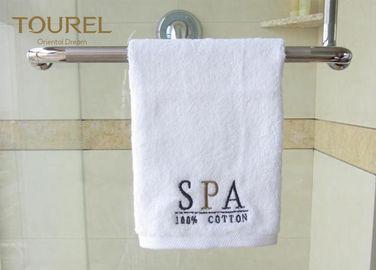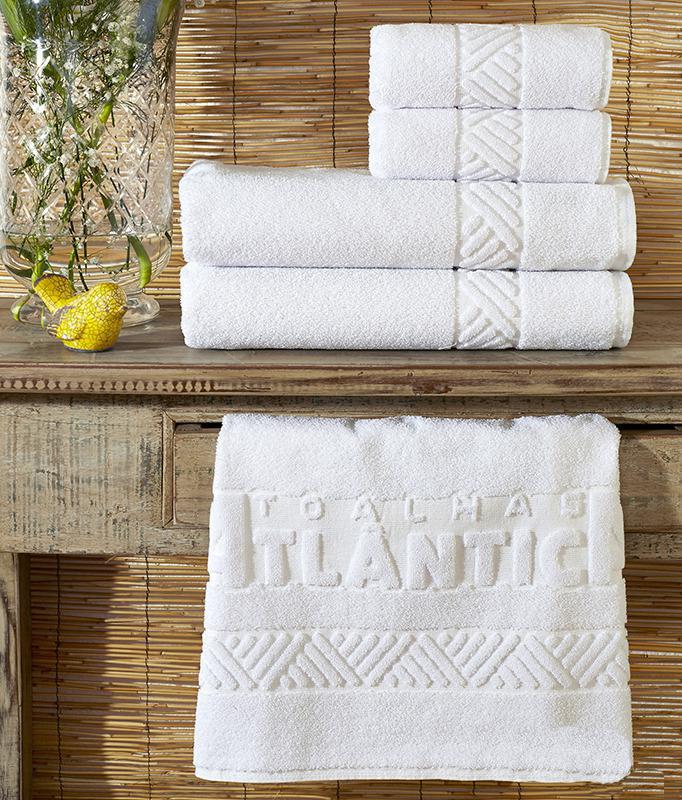The first image is the image on the left, the second image is the image on the right. Considering the images on both sides, is "The left image shows three white towels with the Sheraton logo stacked on top of each other." valid? Answer yes or no. No. The first image is the image on the left, the second image is the image on the right. Considering the images on both sides, is "In one of the images, four towels are stacked in a single stack." valid? Answer yes or no. Yes. 